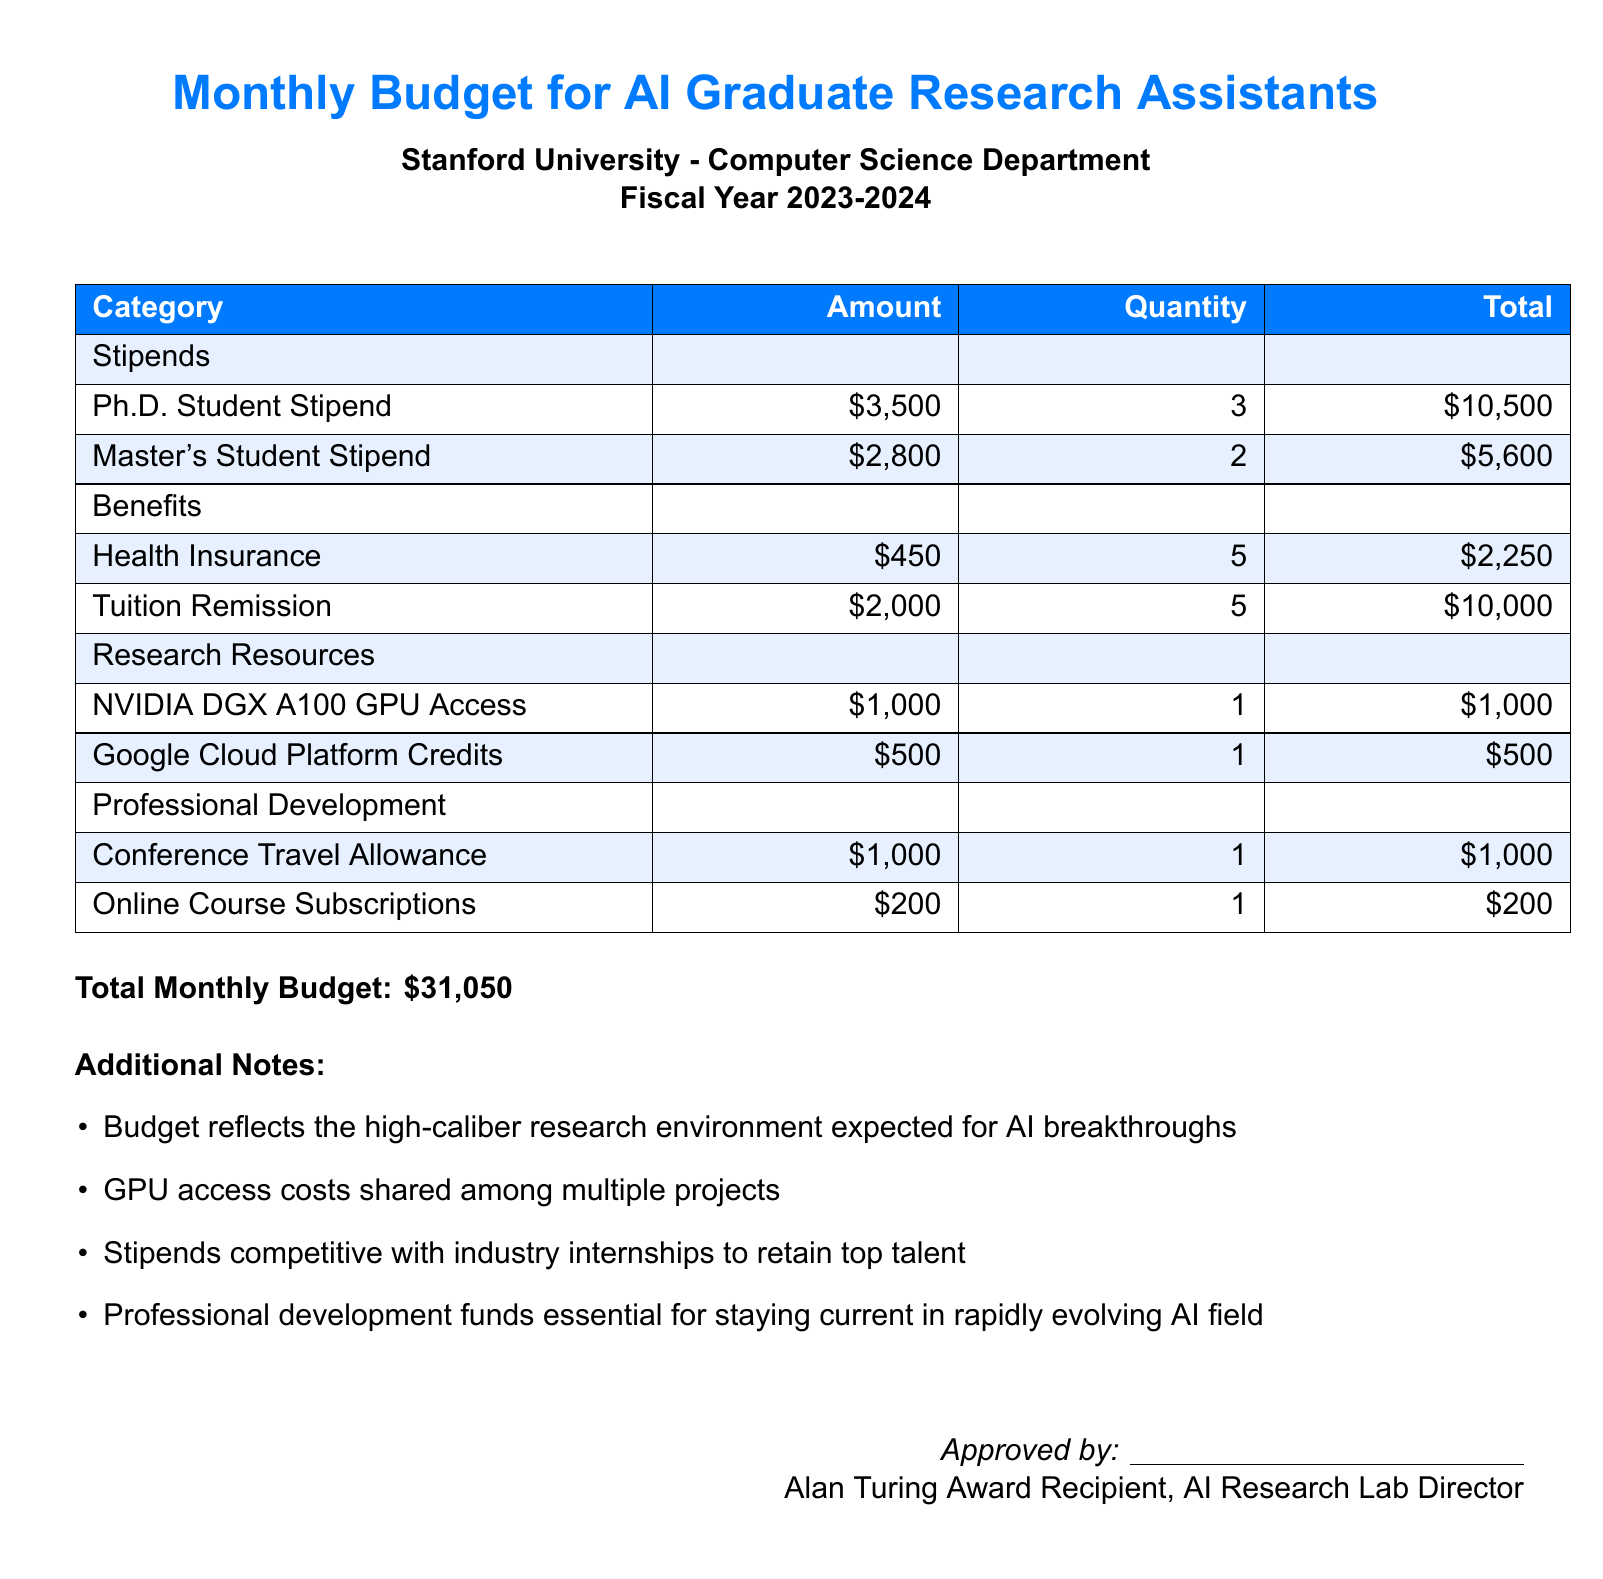What is the total monthly budget? The total monthly budget is stated at the bottom of the document.
Answer: $31,050 How many Ph.D. students are receiving stipends? The number of Ph.D. students is listed in the stipends section of the document.
Answer: 3 What is the cost of Health Insurance per student? The cost of Health Insurance is provided in the benefits section.
Answer: $450 How much does NVIDIA DGX A100 GPU Access cost? This cost is listed under the research resources category.
Answer: $1,000 What is the tuition remission total for all students? The total for tuition remission is obtained by multiplying the cost by the quantity of students.
Answer: $10,000 What is the allowance for Conference Travel? This amount is specified under the professional development section of the document.
Answer: $1,000 What is the stipend for a Master's student? The stipend amount for a Master's student is directly mentioned in the stipends section.
Answer: $2,800 How many graduate research assistants qualify for tuition remission? The document states the quantity of students that qualify for tuition remission under benefits.
Answer: 5 